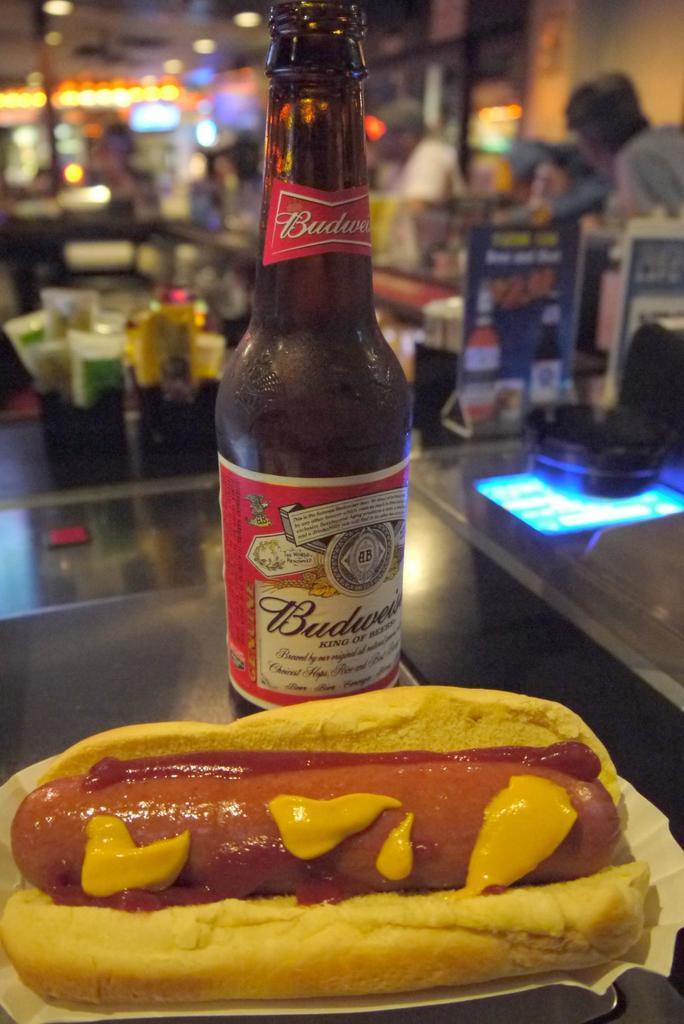Please provide a concise description of this image. In this image we can see a chili dog and one bottle. Behind so many things are present. 